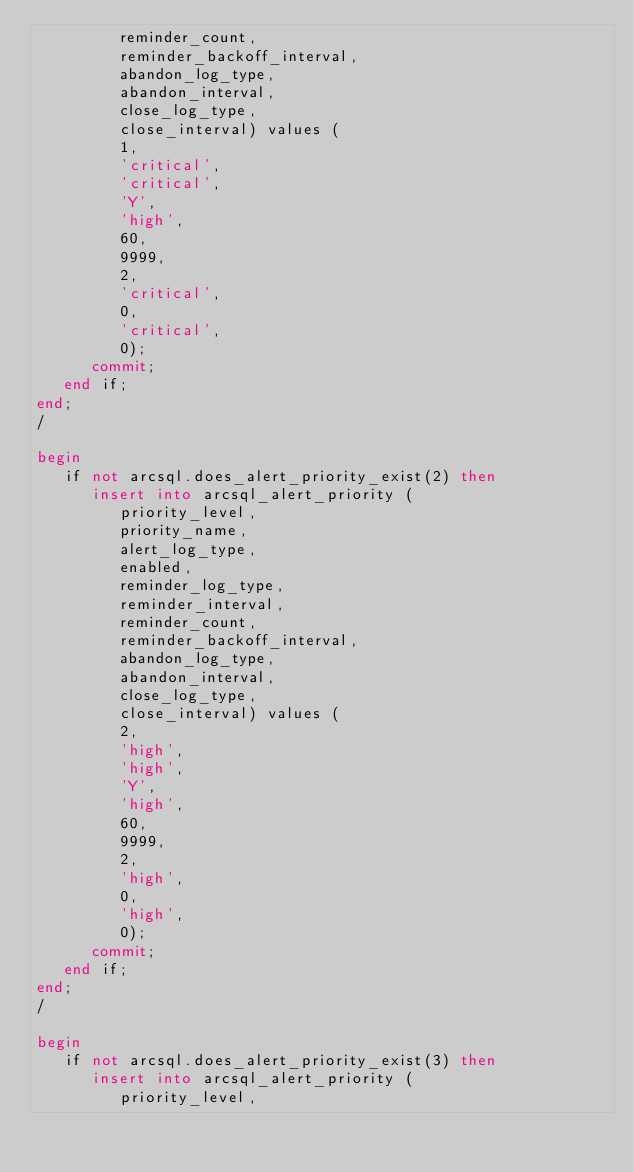<code> <loc_0><loc_0><loc_500><loc_500><_SQL_>         reminder_count,
         reminder_backoff_interval,
         abandon_log_type,
         abandon_interval,
         close_log_type,
         close_interval) values (
         1,
         'critical',
         'critical',
         'Y',
         'high',
         60,
         9999,
         2,
         'critical',
         0,
         'critical',
         0);
      commit;
   end if;
end;
/

begin
   if not arcsql.does_alert_priority_exist(2) then 
      insert into arcsql_alert_priority (
         priority_level,
         priority_name,
         alert_log_type,
         enabled,
         reminder_log_type,
         reminder_interval,
         reminder_count,
         reminder_backoff_interval,
         abandon_log_type,
         abandon_interval,
         close_log_type,
         close_interval) values (
         2,
         'high',
         'high',
         'Y',
         'high',
         60,
         9999,
         2,
         'high',
         0,
         'high',
         0);
      commit;
   end if;
end;
/

begin
   if not arcsql.does_alert_priority_exist(3) then 
      insert into arcsql_alert_priority (
         priority_level,</code> 